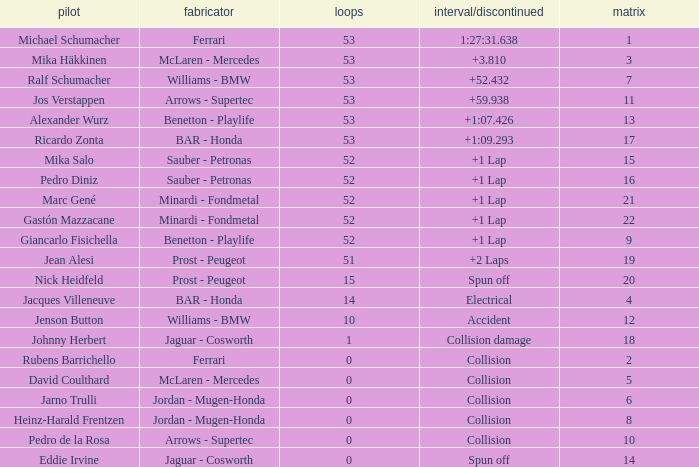What is the name of the driver with a grid less than 14, laps smaller than 53 and a Time/Retired of collision, and a Constructor of ferrari? Rubens Barrichello. 